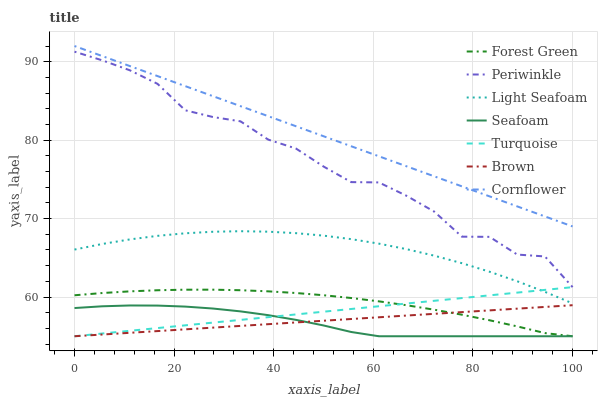Does Seafoam have the minimum area under the curve?
Answer yes or no. Yes. Does Cornflower have the maximum area under the curve?
Answer yes or no. Yes. Does Turquoise have the minimum area under the curve?
Answer yes or no. No. Does Turquoise have the maximum area under the curve?
Answer yes or no. No. Is Brown the smoothest?
Answer yes or no. Yes. Is Periwinkle the roughest?
Answer yes or no. Yes. Is Turquoise the smoothest?
Answer yes or no. No. Is Turquoise the roughest?
Answer yes or no. No. Does Brown have the lowest value?
Answer yes or no. Yes. Does Cornflower have the lowest value?
Answer yes or no. No. Does Cornflower have the highest value?
Answer yes or no. Yes. Does Turquoise have the highest value?
Answer yes or no. No. Is Forest Green less than Periwinkle?
Answer yes or no. Yes. Is Cornflower greater than Light Seafoam?
Answer yes or no. Yes. Does Turquoise intersect Forest Green?
Answer yes or no. Yes. Is Turquoise less than Forest Green?
Answer yes or no. No. Is Turquoise greater than Forest Green?
Answer yes or no. No. Does Forest Green intersect Periwinkle?
Answer yes or no. No. 